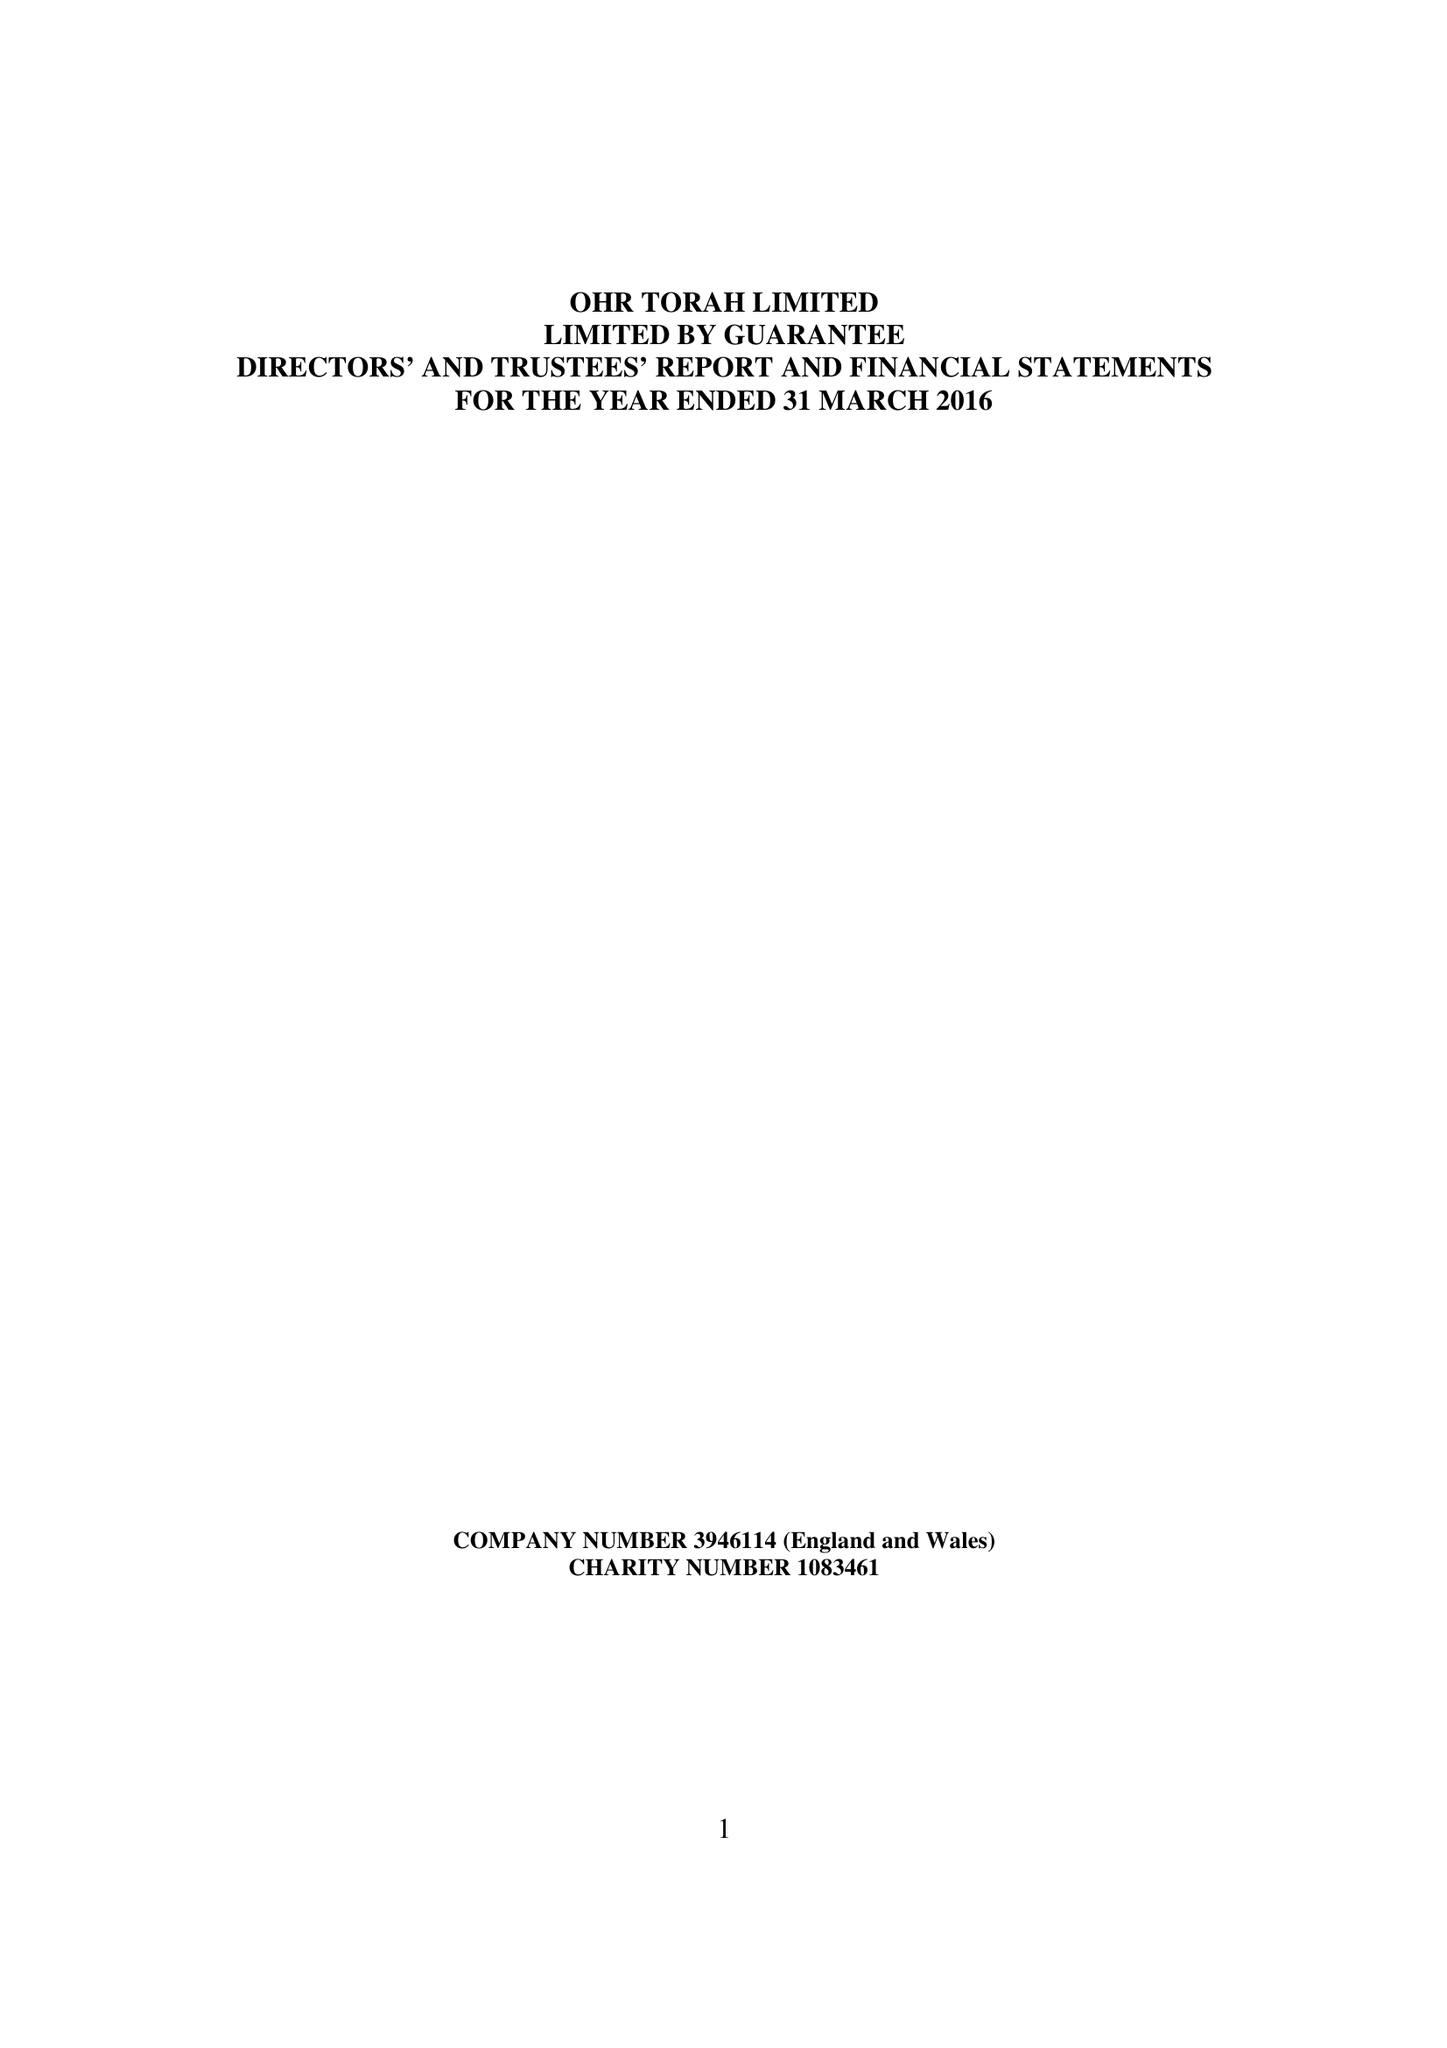What is the value for the address__street_line?
Answer the question using a single word or phrase. 3 MIDDLETON ROAD 